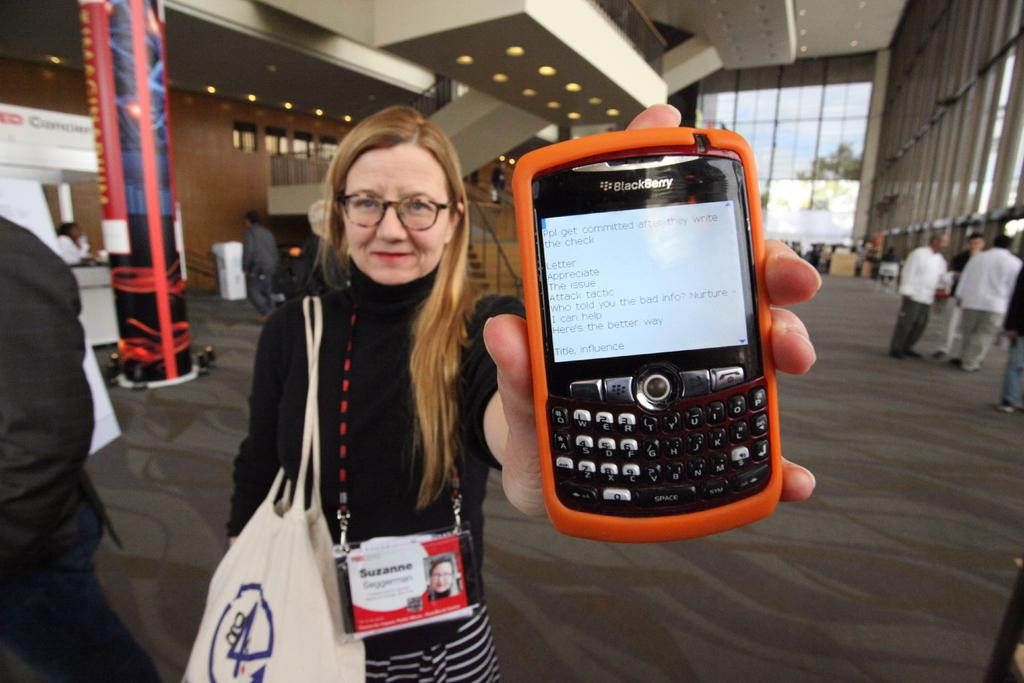<image>
Offer a succinct explanation of the picture presented. A woman holding up a phone from the Blackberry brand 